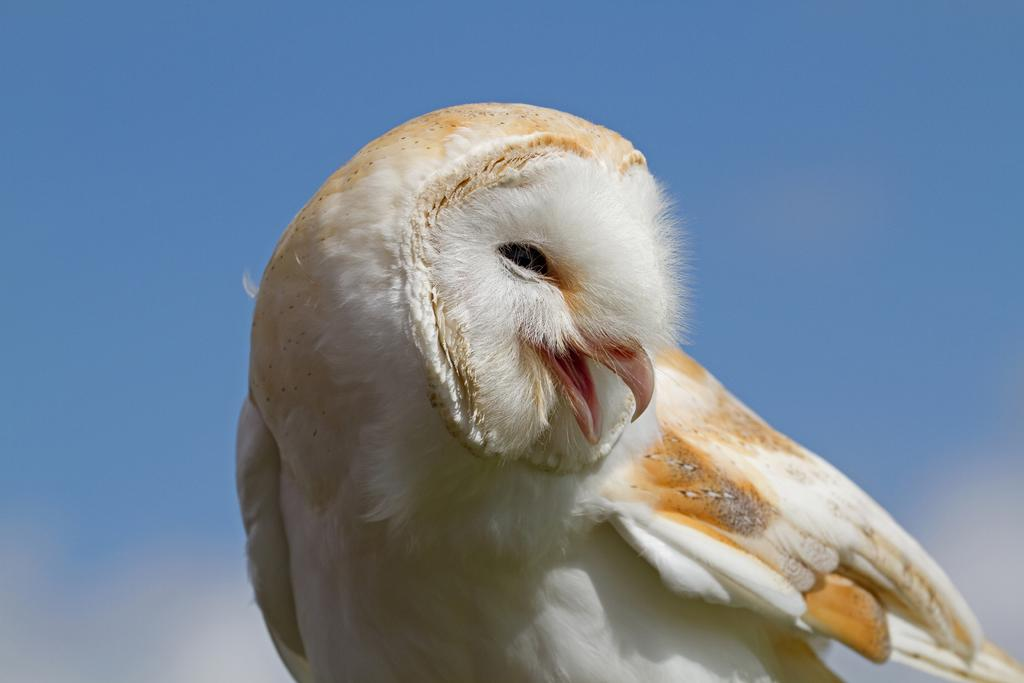What type of animal is in the picture? There is a bird in the picture. What color is the bird? The bird is white in color, with some parts being cream in color. What can be seen in the background of the picture? The sky is visible behind the bird. What type of coach is present in the picture? There is no coach present in the picture; it features a bird. What punishment is the bird receiving in the picture? There is no punishment being given to the bird in the picture; it is simply perched or flying. 